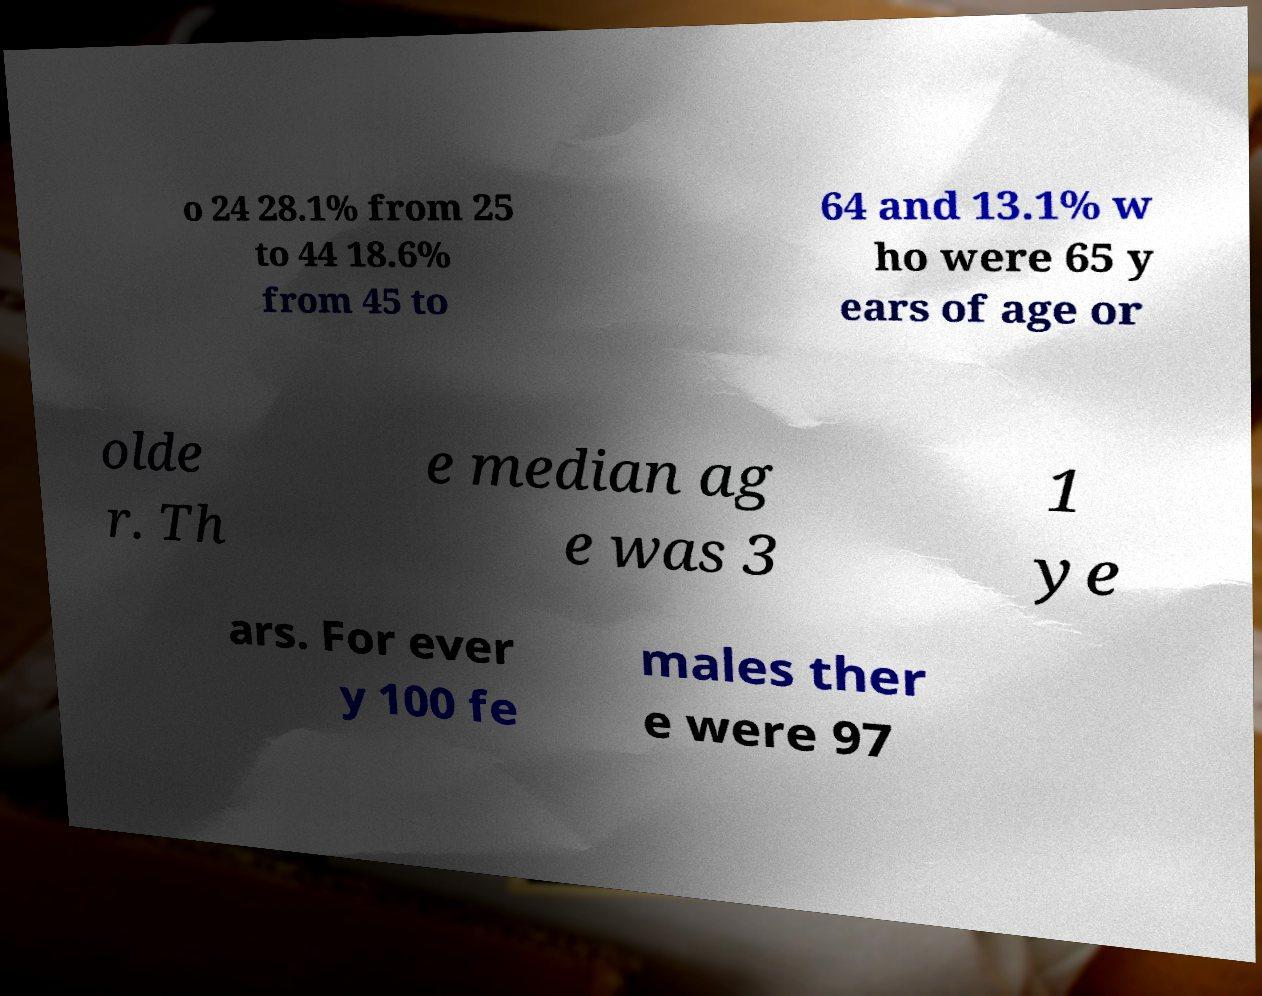Can you read and provide the text displayed in the image?This photo seems to have some interesting text. Can you extract and type it out for me? o 24 28.1% from 25 to 44 18.6% from 45 to 64 and 13.1% w ho were 65 y ears of age or olde r. Th e median ag e was 3 1 ye ars. For ever y 100 fe males ther e were 97 